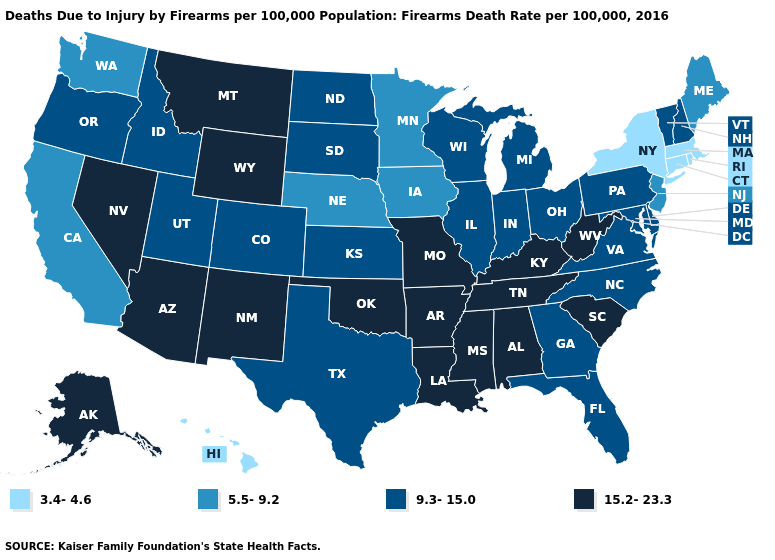What is the highest value in states that border Minnesota?
Give a very brief answer. 9.3-15.0. What is the lowest value in the USA?
Short answer required. 3.4-4.6. What is the value of Georgia?
Be succinct. 9.3-15.0. Does Virginia have a lower value than Connecticut?
Keep it brief. No. What is the value of Montana?
Quick response, please. 15.2-23.3. Name the states that have a value in the range 3.4-4.6?
Short answer required. Connecticut, Hawaii, Massachusetts, New York, Rhode Island. Does the first symbol in the legend represent the smallest category?
Short answer required. Yes. What is the value of North Dakota?
Keep it brief. 9.3-15.0. Does Connecticut have the lowest value in the USA?
Keep it brief. Yes. Does Indiana have a higher value than Massachusetts?
Give a very brief answer. Yes. What is the value of West Virginia?
Keep it brief. 15.2-23.3. Which states have the lowest value in the USA?
Be succinct. Connecticut, Hawaii, Massachusetts, New York, Rhode Island. Name the states that have a value in the range 9.3-15.0?
Give a very brief answer. Colorado, Delaware, Florida, Georgia, Idaho, Illinois, Indiana, Kansas, Maryland, Michigan, New Hampshire, North Carolina, North Dakota, Ohio, Oregon, Pennsylvania, South Dakota, Texas, Utah, Vermont, Virginia, Wisconsin. 